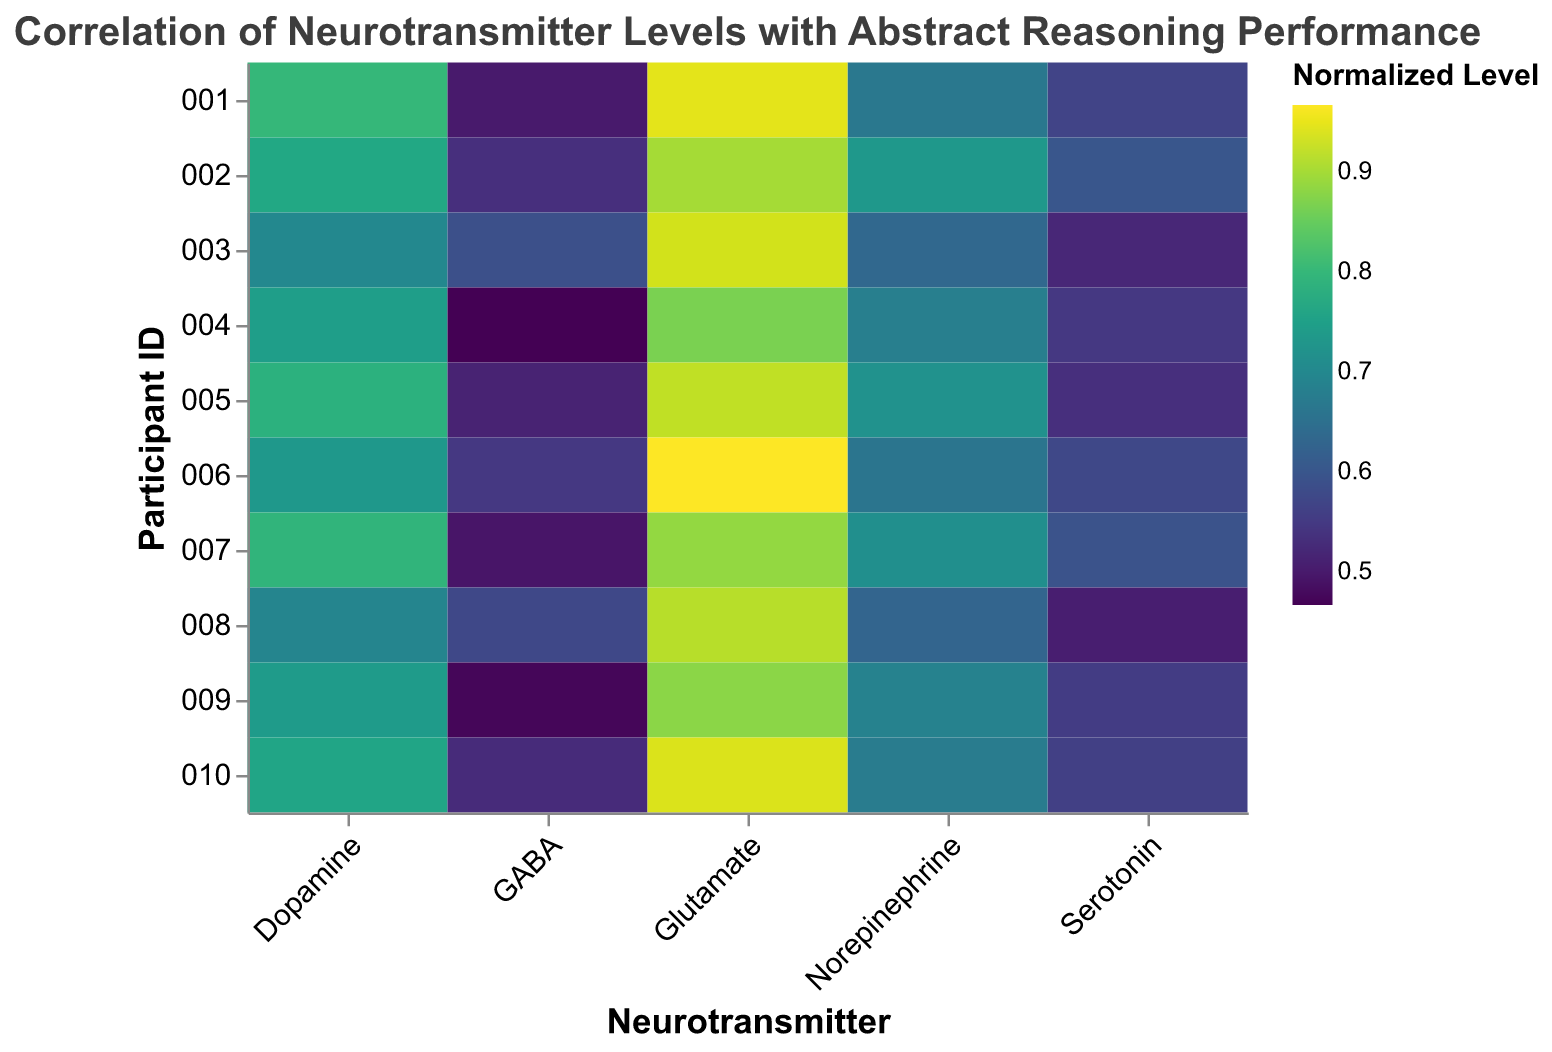What is the title of the plot? The title of the plot is located at the top of the figure and provides the main topic of the visualization.
Answer: Correlation of Neurotransmitter Levels with Abstract Reasoning Performance Which neurotransmitter has the highest normalized level for Participant 003? To find the highest normalized level for Participant 003, locate the row corresponding to Participant 003 and compare the color intensity of each neurotransmitter's rectangle. The highest intensity/color points to the highest normalized level.
Answer: Glutamate How does the normalized level of Serotonin compare between Participant 002 and Participant 010? Look at the color intensities in the Serotonin column for Participant 002 and Participant 010. The participant with a lighter color value has a higher normalized serotonin level.
Answer: Participant 002 has a higher normalized level than Participant 010 Which neurotransmitter shows the most consistent normalized level across all participants? To determine consistency, compare the color distribution within each neurotransmitter column. The neurotransmitter with the least variation in color intensity among participants is the most consistent.
Answer: Glutamate How does the average normalized level of Dopamine compare to that of GABA? For Dopamine and GABA, find the average color intensity across all participants. Sum the normalized values of each participant for Dopamine and GABA separately and then divide by the number of participants (10). Compare these two average values to see which neurotransmitter has a higher average normalized level.
Answer: Dopamine has a higher average normalized level than GABA Which participant has the highest abstract reasoning score and what is their normalized level of Glutamate? First, identify the participant with the highest abstract reasoning score by looking at the data provided. Then, find the corresponding row for that participant and check the normalized level of Glutamate in the heatmap.
Answer: Participant 002, normalized Glutamate level is 0.90 Is there a visible correlation between normalized levels of Serotonin and Abstract Reasoning Score? Compare the intensity of normalized levels of Serotonin with the performance scores across participants. If higher serotonin levels correspond to higher scores frequently, it suggests a correlation.
Answer: There appears to be a positive correlation What relationship can you infer between GABA levels and abstract reasoning performance? Analyze the spread of normalized GABA levels across participants and compare it to their reasoning scores. Noting the patterns can help infer whether higher/lower GABA levels align with higher/lower abstract reasoning performance.
Answer: Higher GABA levels do not consistently relate to higher abstract reasoning performance Which neurotransmitter has the widest range of normalized levels across participants? Assess the color gradient variation within each neurotransmitter's column. The one with the biggest difference between the darkest and lightest colors (widest range of normalized values) is the neurotransmitter with the widest range.
Answer: Serotonin Are there any participants with higher than average levels of both Dopamine and Serotonin? Calculate the average normalized levels of Dopamine and Serotonin across all participants. Identify participants whose normalized values for both neurotransmitters exceed these averages.
Answer: Participants 002, 006, and 007 have higher than average levels of both Dopamine and Serotonin 